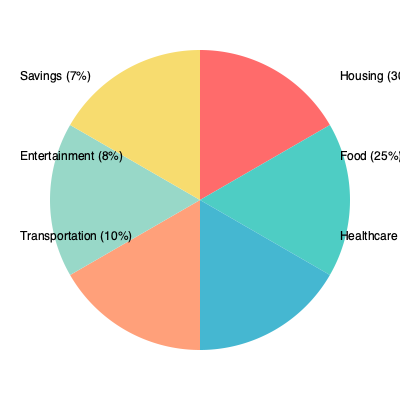Based on the pie chart depicting household expenditure during an economic downturn, which category shows the most significant shift in spending priorities, and how might this impact an individual's financial stability? To answer this question, we need to analyze the pie chart and consider the implications of each category on an individual's financial stability during an economic downturn:

1. Housing (30%): This is the largest expense, which is typical. During a downturn, housing costs are often fixed and difficult to reduce quickly.

2. Food (25%): The second-largest category, indicating a significant portion of the budget goes to essential needs.

3. Healthcare (20%): A considerable portion of the budget, suggesting increased healthcare costs or prioritization during economic hardship.

4. Transportation (10%): A smaller but still significant portion of expenses.

5. Entertainment (8%): Reduced compared to what might be expected in normal economic conditions, indicating potential cutbacks in discretionary spending.

6. Savings (7%): A relatively small portion of the budget is allocated to savings.

The most significant shift in spending priorities appears to be the reduced allocation to savings and entertainment, with a corresponding increase in essential categories like housing, food, and healthcare. This shift impacts an individual's financial stability in several ways:

1. Reduced ability to build an emergency fund or save for future goals.
2. Increased vulnerability to unexpected expenses or further economic shocks.
3. Potential for increased stress due to financial constraints and reduced leisure activities.
4. Greater focus on meeting immediate, essential needs rather than long-term financial planning.

The low savings rate (7%) is particularly concerning, as it limits an individual's ability to weather future economic challenges or unexpected expenses, potentially leading to a cycle of financial instability.
Answer: Reduced savings (7%), impacting long-term financial stability and resilience to future economic shocks. 